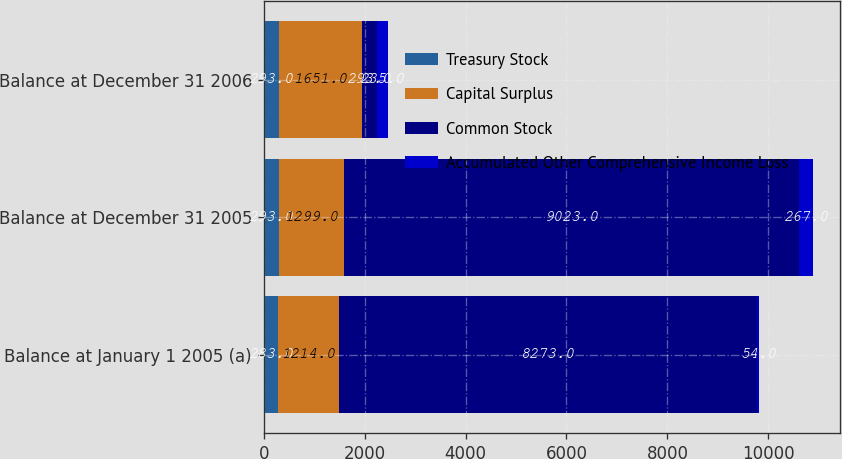<chart> <loc_0><loc_0><loc_500><loc_500><stacked_bar_chart><ecel><fcel>Balance at January 1 2005 (a)<fcel>Balance at December 31 2005<fcel>Balance at December 31 2006<nl><fcel>Treasury Stock<fcel>283<fcel>293<fcel>293<nl><fcel>Capital Surplus<fcel>1214<fcel>1299<fcel>1651<nl><fcel>Common Stock<fcel>8273<fcel>9023<fcel>293<nl><fcel>Accumulated Other Comprehensive Income Loss<fcel>54<fcel>267<fcel>235<nl></chart> 